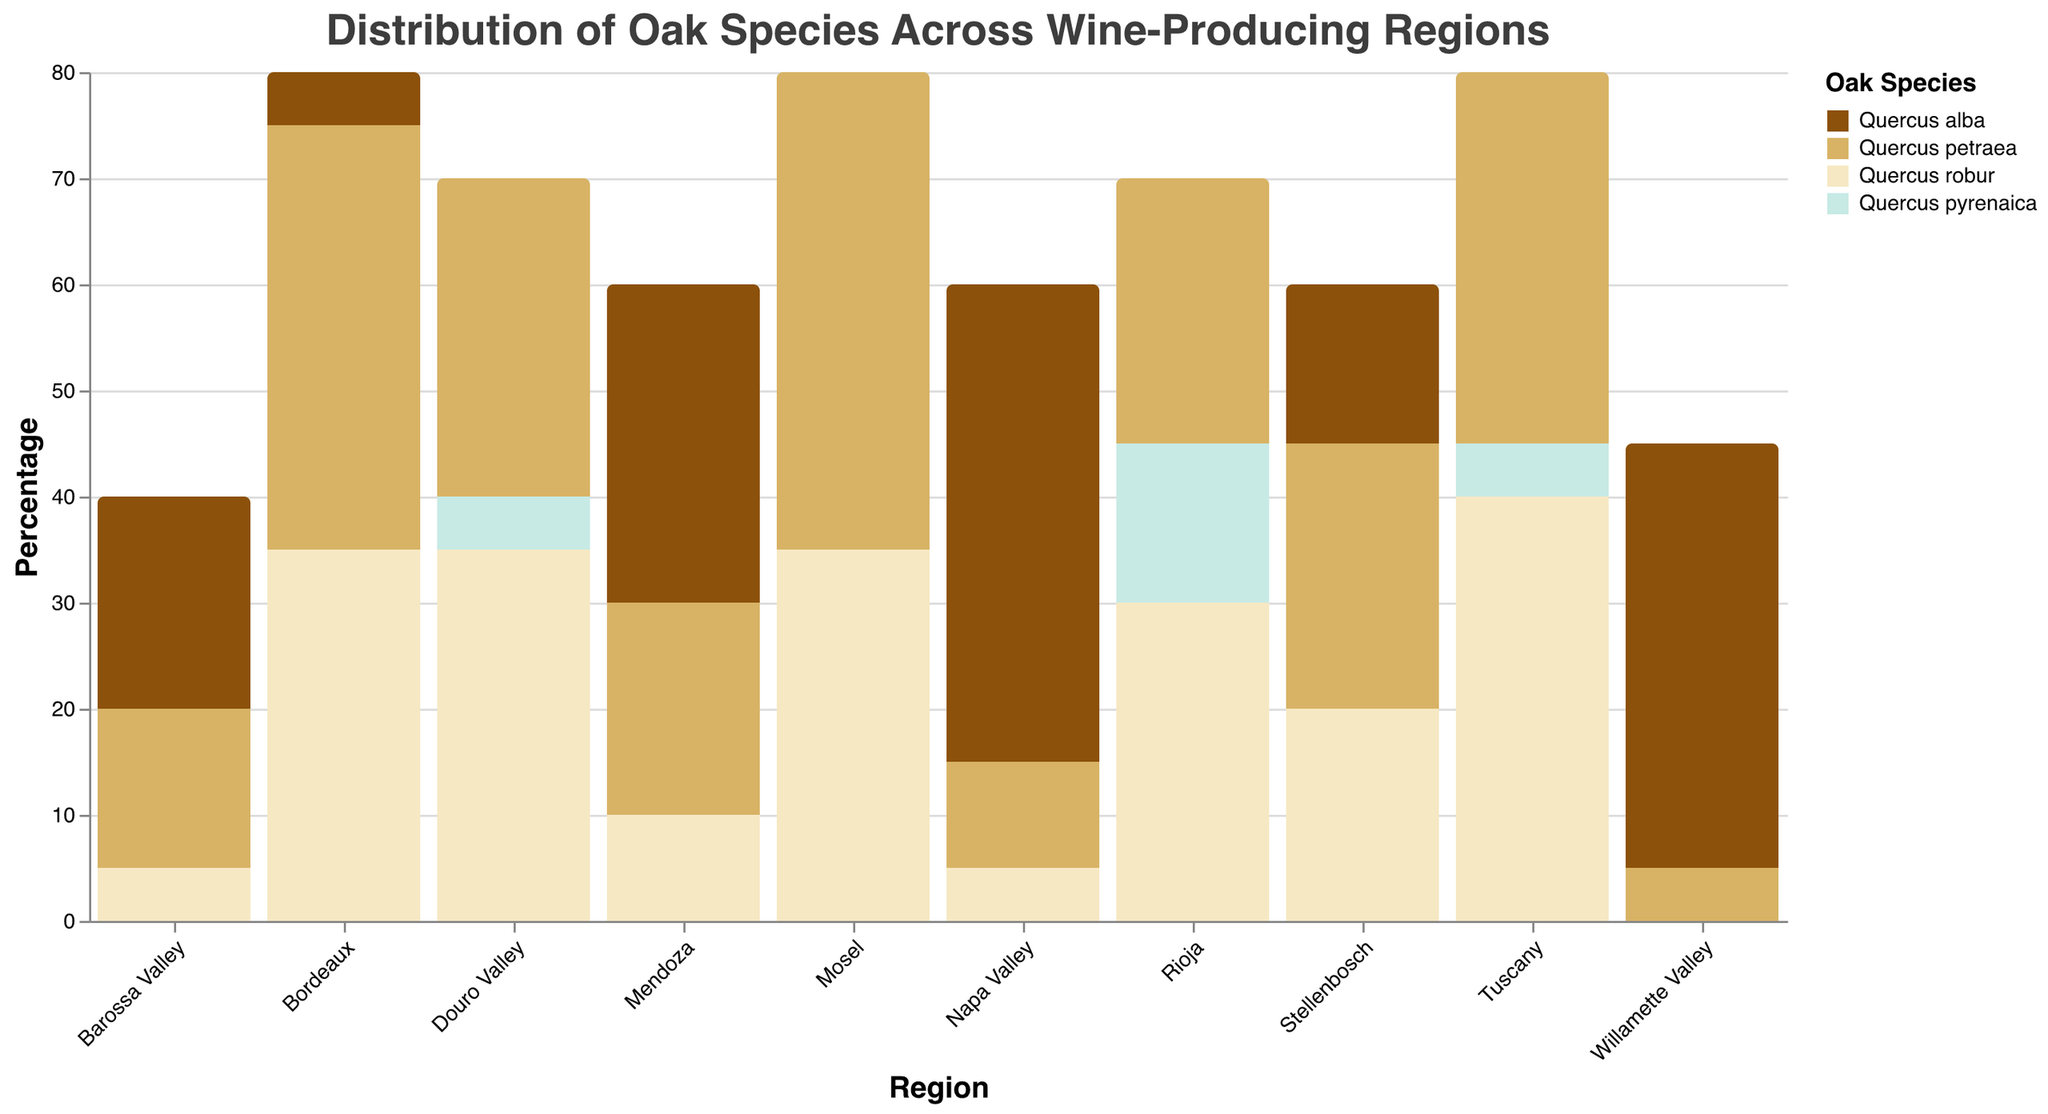What is the title of the figure? The title is usually displayed at the top of the figure. It provides an overview of the information visually represented.
Answer: Distribution of Oak Species Across Wine-Producing Regions Which region uses the highest percentage of Quercus alba? To find the answer, look at the bars corresponding to Quercus alba color and determine the tallest bar for this oak species amongst the regions.
Answer: Napa Valley Compare the usage of Quercus petraea in Bordeaux and Mendoza. Which region has a higher percentage? Both Bordeaux and Mendoza are displayed on the x-axis. By comparing the heights of the two bars representing Quercus petraea, it’s clear which region has a greater percentage.
Answer: Bordeaux What is the combined percentage of Quercus robur in all European regions shown in the figure? Identify the regions in Europe (Bordeaux, Rioja, Tuscany, Mosel, Douro Valley) and sum the percentages of Quercus robur for these regions: 35 + 30 + 40 + 35 + 35 = 175.
Answer: 175% Does any region not use Quercus pyrenaica at all? If so, name it. Check the bars colored for Quercus pyrenaica in each region. Identify if any region has a bar height of zero for this oak species.
Answer: Napa Valley, Barossa Valley, Mendoza, Mosel, Willamette Valley, Stellenbosch Which oak species is never used in the Napa Valley region? Look at the data for Napa Valley and identify which oak species has a percentage of zero.
Answer: Quercus pyrenaica Which region has the smallest diversity in oak species usage, using the least number of different oak types? Look at the number of different types of bars (colors) present in each region and identify the region with the fewest different types of oak species.
Answer: Willamette Valley How does the usage of Quercus robor in Tuscany compare to Bordeaux? Examine the heights of the bars representing Quercus robor in Tuscany and Bordeaux. Compare to see which is higher.
Answer: Tuscany has a higher percentage Calculate the average percentage of Quercus petraea across all regions. Add the percentages of Quercus petraea in all regions and divide by the number of regions: (10 + 40 + 25 + 35 + 15 + 20 + 45 + 30 + 5 + 25) / 10 = 250 / 10 = 25.
Answer: 25% In which region do we see the maximum use of Quercus pyrenaica? Identify the highest bar corresponding to Quercus pyrenaica from the plot.
Answer: Rioja 